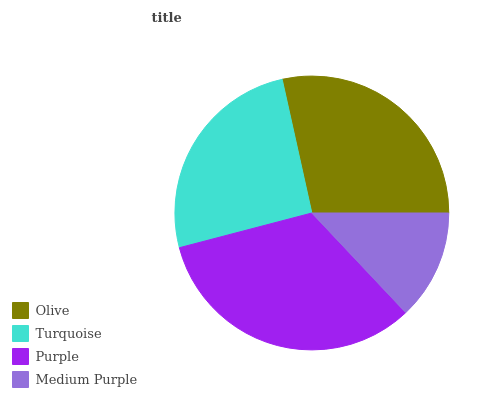Is Medium Purple the minimum?
Answer yes or no. Yes. Is Purple the maximum?
Answer yes or no. Yes. Is Turquoise the minimum?
Answer yes or no. No. Is Turquoise the maximum?
Answer yes or no. No. Is Olive greater than Turquoise?
Answer yes or no. Yes. Is Turquoise less than Olive?
Answer yes or no. Yes. Is Turquoise greater than Olive?
Answer yes or no. No. Is Olive less than Turquoise?
Answer yes or no. No. Is Olive the high median?
Answer yes or no. Yes. Is Turquoise the low median?
Answer yes or no. Yes. Is Purple the high median?
Answer yes or no. No. Is Medium Purple the low median?
Answer yes or no. No. 